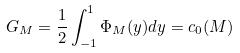Convert formula to latex. <formula><loc_0><loc_0><loc_500><loc_500>G _ { M } = \frac { 1 } { 2 } \int _ { - 1 } ^ { 1 } \Phi _ { M } ( y ) d y = c _ { 0 } ( M )</formula> 